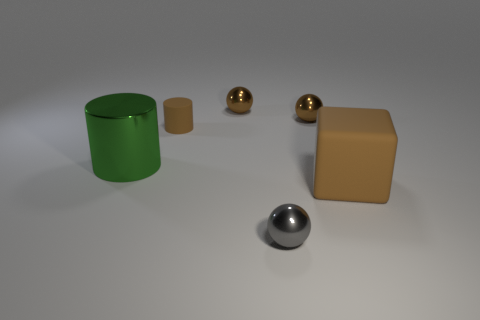Add 3 tiny rubber cylinders. How many objects exist? 9 Subtract all cubes. How many objects are left? 5 Add 3 big metal cylinders. How many big metal cylinders are left? 4 Add 1 large gray blocks. How many large gray blocks exist? 1 Subtract 0 yellow cubes. How many objects are left? 6 Subtract all big blue metallic cylinders. Subtract all large matte blocks. How many objects are left? 5 